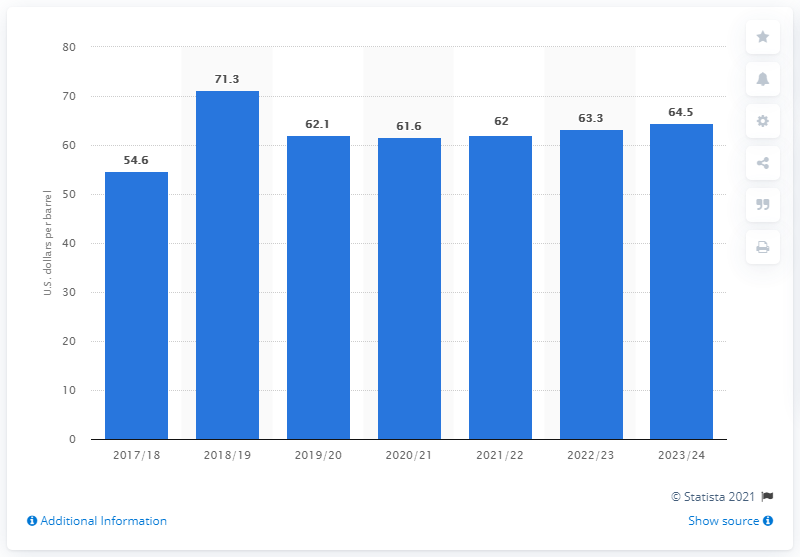Highlight a few significant elements in this photo. The forecasted price of oil in the UK from 2017 to 2024 is expected to be x U.S. dollars per barrel. It is expected that the price of oil will increase to $64.5 in US dollars in the year 2023/24. 